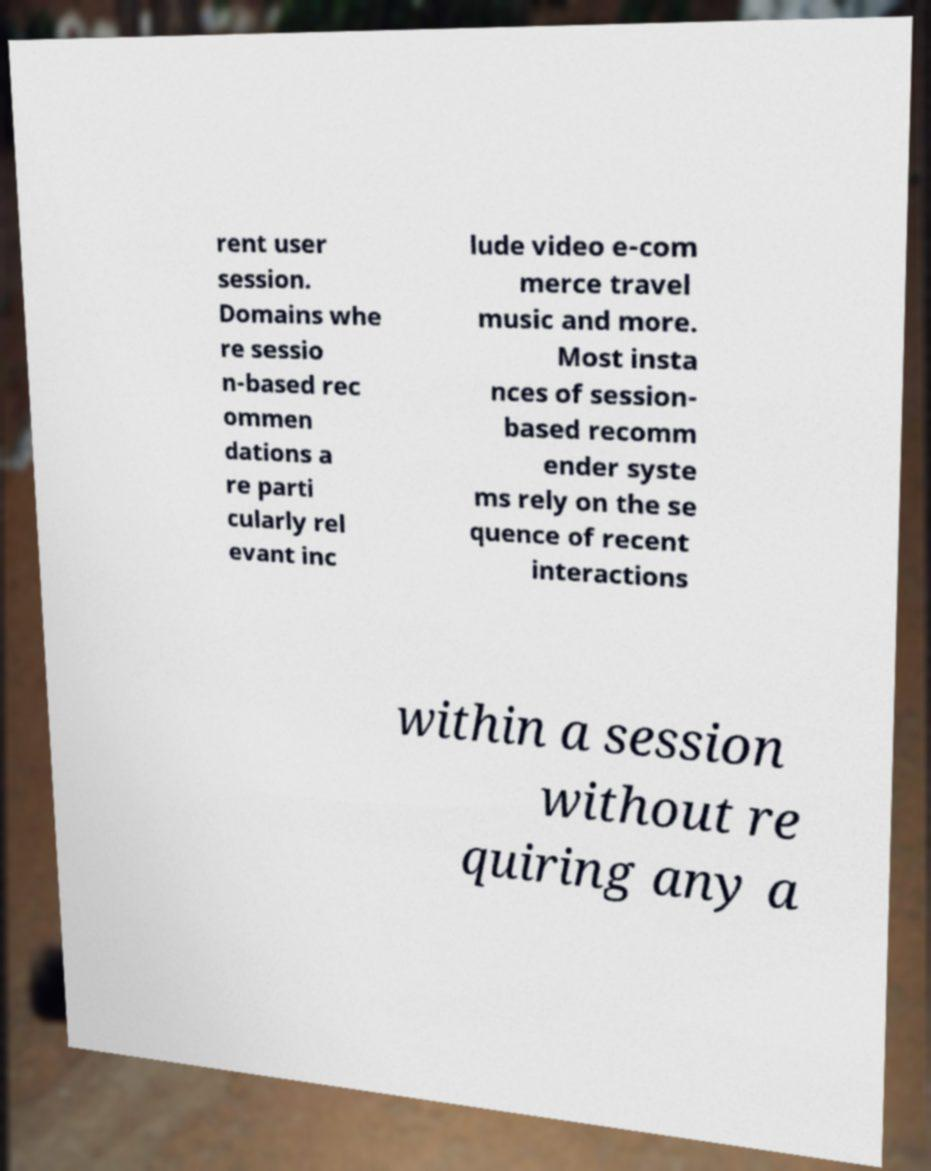Can you read and provide the text displayed in the image?This photo seems to have some interesting text. Can you extract and type it out for me? rent user session. Domains whe re sessio n-based rec ommen dations a re parti cularly rel evant inc lude video e-com merce travel music and more. Most insta nces of session- based recomm ender syste ms rely on the se quence of recent interactions within a session without re quiring any a 